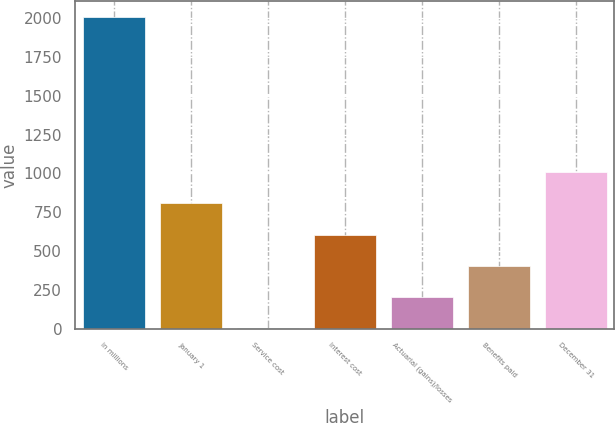Convert chart. <chart><loc_0><loc_0><loc_500><loc_500><bar_chart><fcel>in millions<fcel>January 1<fcel>Service cost<fcel>Interest cost<fcel>Actuarial (gains)/losses<fcel>Benefits paid<fcel>December 31<nl><fcel>2010<fcel>806.46<fcel>4.1<fcel>605.87<fcel>204.69<fcel>405.28<fcel>1007.05<nl></chart> 